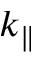<formula> <loc_0><loc_0><loc_500><loc_500>k _ { \| }</formula> 